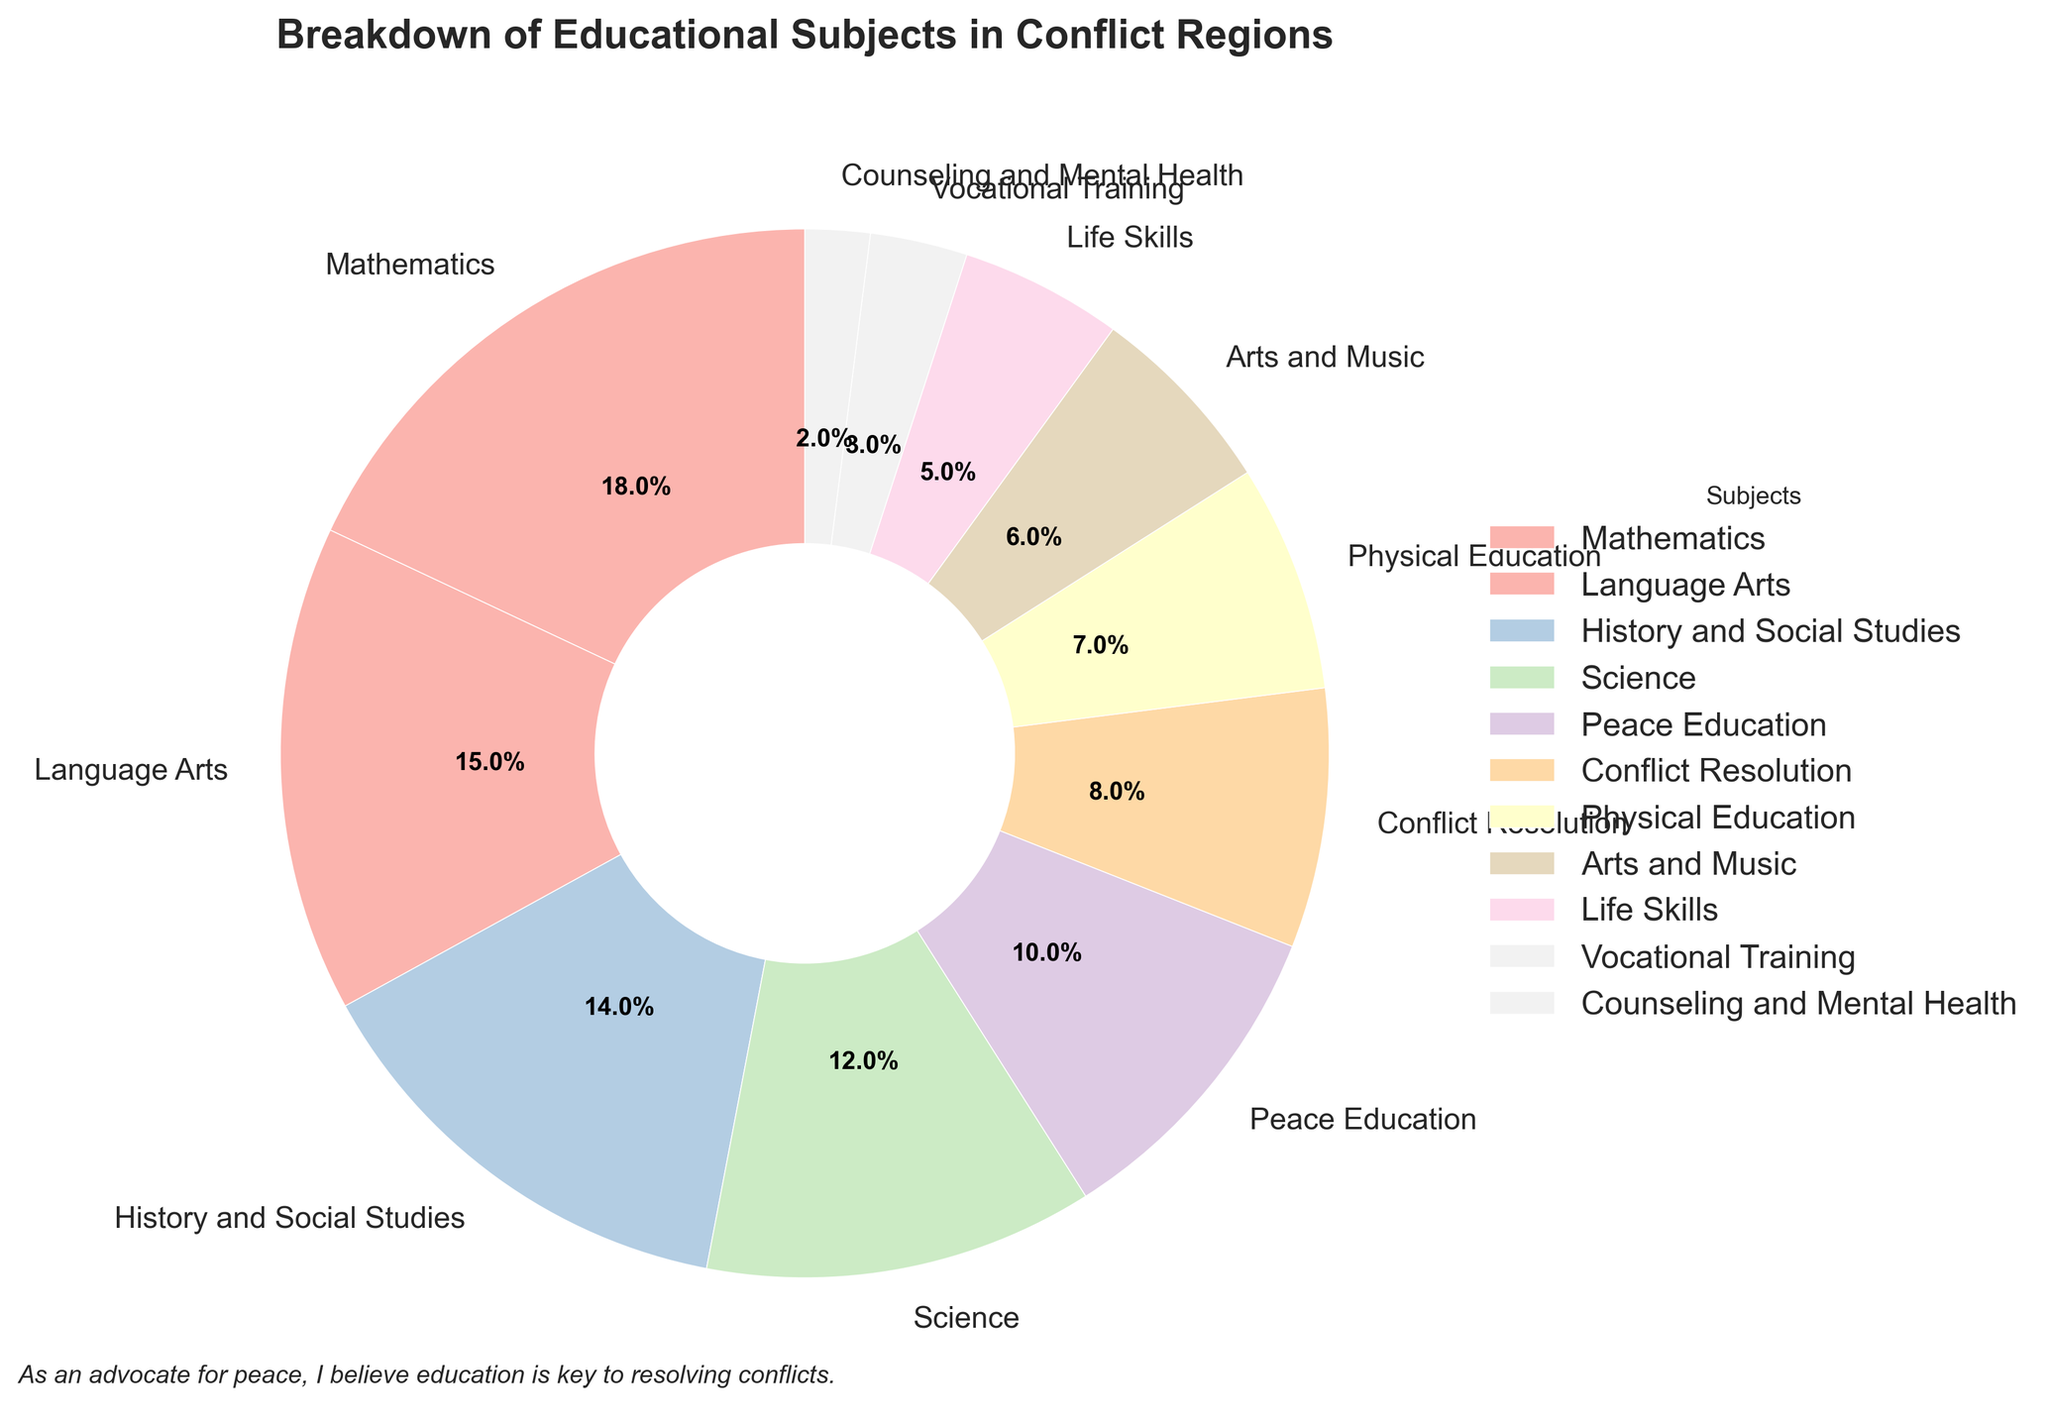What is the percentage of schools that teach Mathematics? From the pie chart, locate the segment labeled "Mathematics" and read its associated percentage value.
Answer: 18% Which subject has a smaller percentage of coverage than Peace Education but larger than Physical Education? First, identify the percentage for Peace Education (10%) and Physical Education (7%). The subject must have a percentage between these two values. Check the remaining subjects to find that Conflict Resolution (8%) is the subject fitting these criteria.
Answer: Conflict Resolution What are the combined percentages of Science and Arts and Music? Find the percentages for Science and Arts and Music. Add these together: Science (12%) + Arts and Music (6%) = 18%.
Answer: 18% Between Physical Education and Life Skills, which one occupies a larger section of the pie chart? Compare the percentages of Physical Education (7%) and Life Skills (5%). Physical Education has a larger percentage, hence a larger section of the pie chart.
Answer: Physical Education Are the subjects covered by the pie chart exclusive, or do some subjects share the same percentages? Examine the chart segments and their labels. Each subject has a unique percentage ranging from 18% to 2%, indicating that all subjects have distinct percentages.
Answer: Exclusive What is the total percentage of subjects directly related to peace (Peace Education and Conflict Resolution)? Add the percentages of Peace Education (10%) and Conflict Resolution (8%). 10% + 8% = 18%.
Answer: 18% If you add Counseling and Mental Health to Life Skills, what is their total percentage? Locate the percentages for Counseling and Mental Health (2%) and Life Skills (5%). Add these together: 2% + 5% = 7%.
Answer: 7% Which subject has the largest coverage in the chart? Identify the subject with the highest percentage value. Mathematics has the largest segment with 18%.
Answer: Mathematics Between Vocational Training and Counseling and Mental Health, which one has the least percentage? Compare the percentages for Vocational Training (3%) and Counseling and Mental Health (2%). Counseling and Mental Health has the least percentage.
Answer: Counseling and Mental Health What is the average percentage of subjects if we consider only Physical Education, Life Skills, and Vocational Training? Sum the percentages of Physical Education (7%), Life Skills (5%), and Vocational Training (3%). Then divide by the number of subjects (3). (7 + 5 + 3) / 3 = 15 / 3 = 5%.
Answer: 5% 